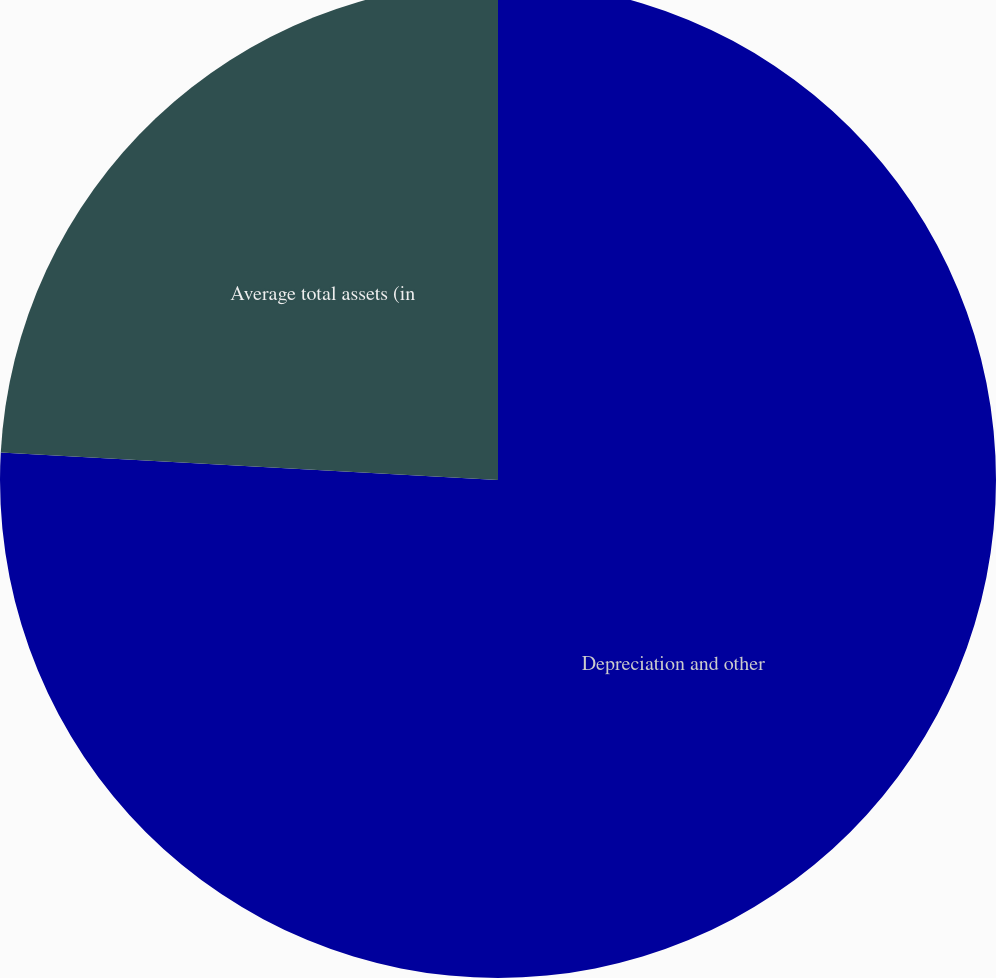Convert chart. <chart><loc_0><loc_0><loc_500><loc_500><pie_chart><fcel>Depreciation and other<fcel>Average total assets (in<nl><fcel>75.88%<fcel>24.12%<nl></chart> 